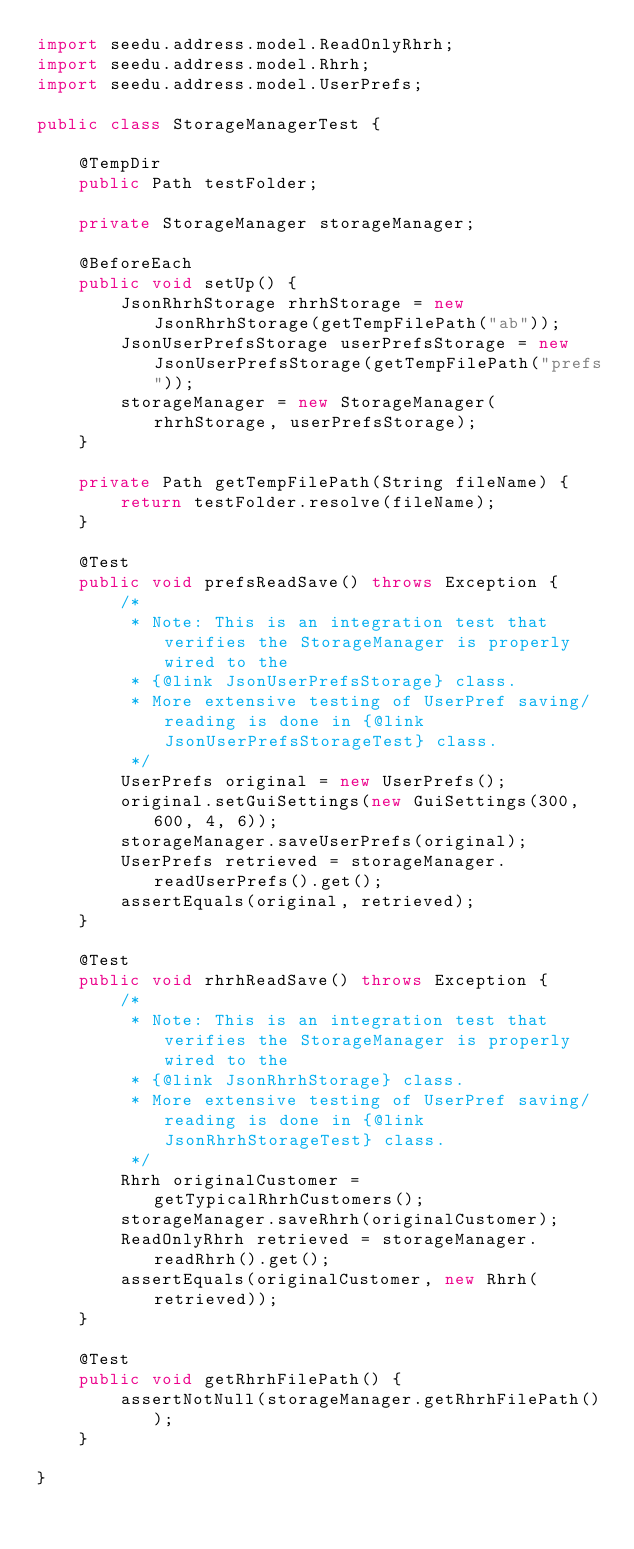Convert code to text. <code><loc_0><loc_0><loc_500><loc_500><_Java_>import seedu.address.model.ReadOnlyRhrh;
import seedu.address.model.Rhrh;
import seedu.address.model.UserPrefs;

public class StorageManagerTest {

    @TempDir
    public Path testFolder;

    private StorageManager storageManager;

    @BeforeEach
    public void setUp() {
        JsonRhrhStorage rhrhStorage = new JsonRhrhStorage(getTempFilePath("ab"));
        JsonUserPrefsStorage userPrefsStorage = new JsonUserPrefsStorage(getTempFilePath("prefs"));
        storageManager = new StorageManager(rhrhStorage, userPrefsStorage);
    }

    private Path getTempFilePath(String fileName) {
        return testFolder.resolve(fileName);
    }

    @Test
    public void prefsReadSave() throws Exception {
        /*
         * Note: This is an integration test that verifies the StorageManager is properly wired to the
         * {@link JsonUserPrefsStorage} class.
         * More extensive testing of UserPref saving/reading is done in {@link JsonUserPrefsStorageTest} class.
         */
        UserPrefs original = new UserPrefs();
        original.setGuiSettings(new GuiSettings(300, 600, 4, 6));
        storageManager.saveUserPrefs(original);
        UserPrefs retrieved = storageManager.readUserPrefs().get();
        assertEquals(original, retrieved);
    }

    @Test
    public void rhrhReadSave() throws Exception {
        /*
         * Note: This is an integration test that verifies the StorageManager is properly wired to the
         * {@link JsonRhrhStorage} class.
         * More extensive testing of UserPref saving/reading is done in {@link JsonRhrhStorageTest} class.
         */
        Rhrh originalCustomer = getTypicalRhrhCustomers();
        storageManager.saveRhrh(originalCustomer);
        ReadOnlyRhrh retrieved = storageManager.readRhrh().get();
        assertEquals(originalCustomer, new Rhrh(retrieved));
    }

    @Test
    public void getRhrhFilePath() {
        assertNotNull(storageManager.getRhrhFilePath());
    }

}
</code> 